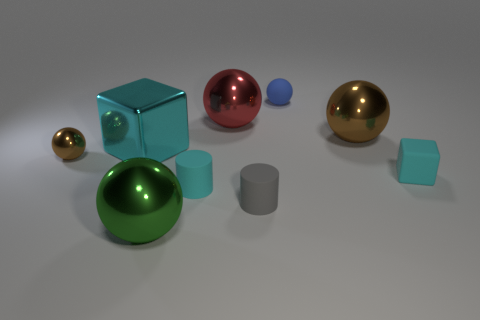How many small cubes are the same material as the tiny cyan cylinder?
Offer a very short reply. 1. How many objects are big things that are right of the blue object or green things?
Your answer should be compact. 2. Is the number of red shiny balls right of the small cyan rubber block less than the number of blocks that are to the left of the tiny brown sphere?
Your answer should be very brief. No. There is a tiny gray rubber object; are there any large green things to the left of it?
Keep it short and to the point. Yes. What number of objects are either large spheres to the right of the green metal ball or big things that are in front of the tiny cube?
Give a very brief answer. 3. What number of things have the same color as the small metal sphere?
Keep it short and to the point. 1. What is the color of the other object that is the same shape as the gray matte thing?
Provide a succinct answer. Cyan. The cyan thing that is both in front of the small brown metallic ball and left of the large brown thing has what shape?
Ensure brevity in your answer.  Cylinder. Is the number of blue things greater than the number of cyan rubber objects?
Offer a very short reply. No. What material is the cyan cylinder?
Your answer should be very brief. Rubber. 